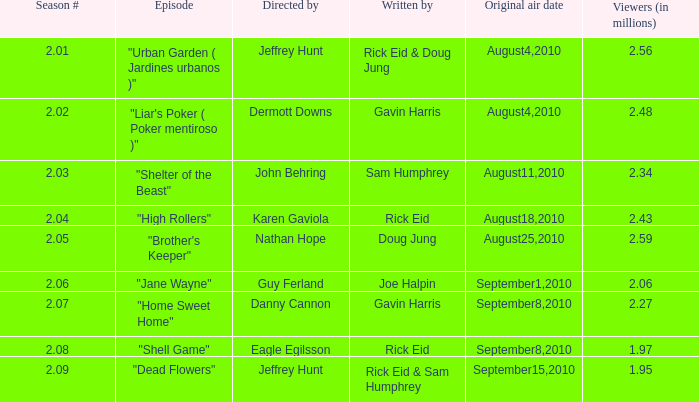If the season number is Rick Eid. 